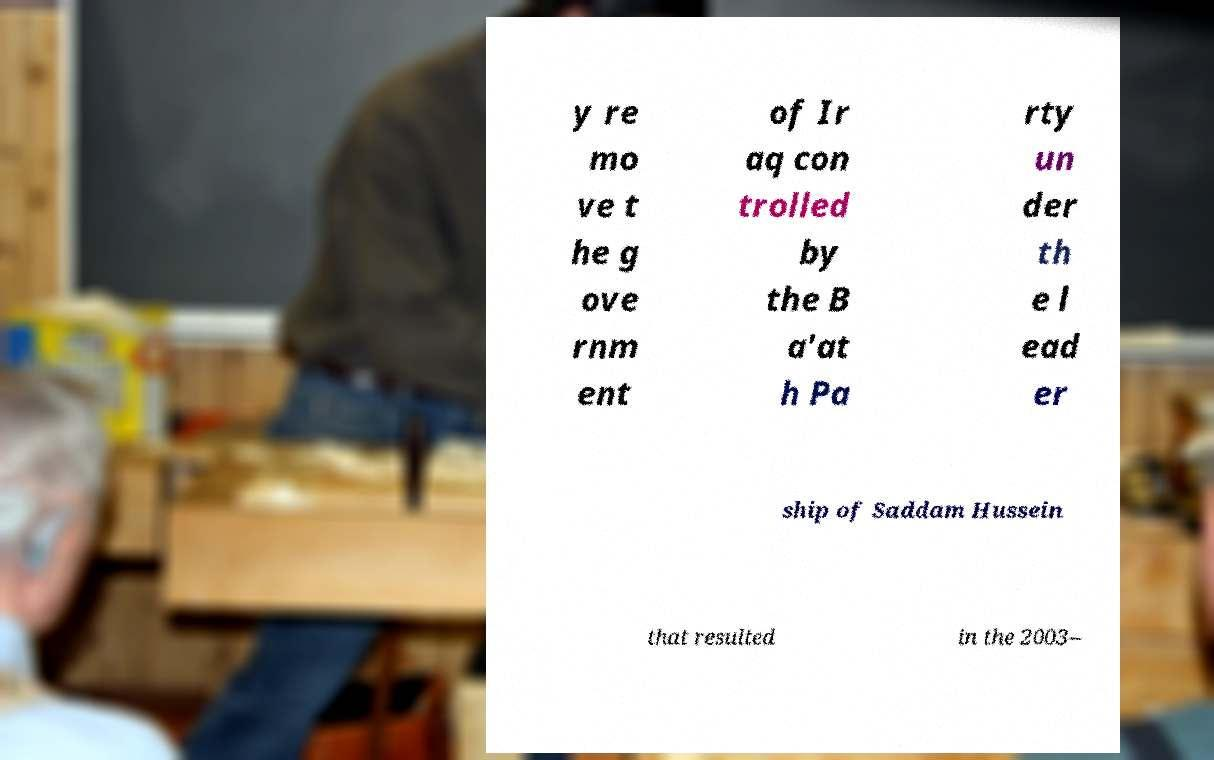For documentation purposes, I need the text within this image transcribed. Could you provide that? y re mo ve t he g ove rnm ent of Ir aq con trolled by the B a'at h Pa rty un der th e l ead er ship of Saddam Hussein that resulted in the 2003– 